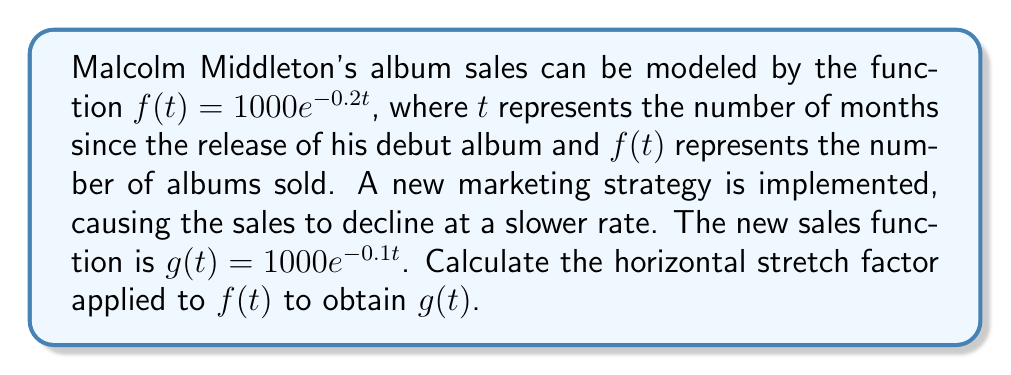Give your solution to this math problem. To find the horizontal stretch factor, we need to compare the equations of $f(t)$ and $g(t)$:

1) Original function: $f(t) = 1000e^{-0.2t}$
2) New function: $g(t) = 1000e^{-0.1t}$

A horizontal stretch by a factor of $k$ transforms a function $f(t)$ into $f(\frac{t}{k})$. In this case, we're looking for $k$ such that:

$f(\frac{t}{k}) = g(t)$

3) Substituting the functions:

   $1000e^{-0.2(\frac{t}{k})} = 1000e^{-0.1t}$

4) The constant factors (1000) are the same, so we can focus on the exponents:

   $-0.2(\frac{t}{k}) = -0.1t$

5) Multiply both sides by $-5$ to simplify:

   $1(\frac{t}{k}) = 0.5t$

6) Solve for $k$:

   $\frac{t}{k} = 0.5t$
   $\frac{1}{k} = 0.5$
   $k = \frac{1}{0.5} = 2$

Therefore, the horizontal stretch factor is 2.
Answer: The horizontal stretch factor is 2. 